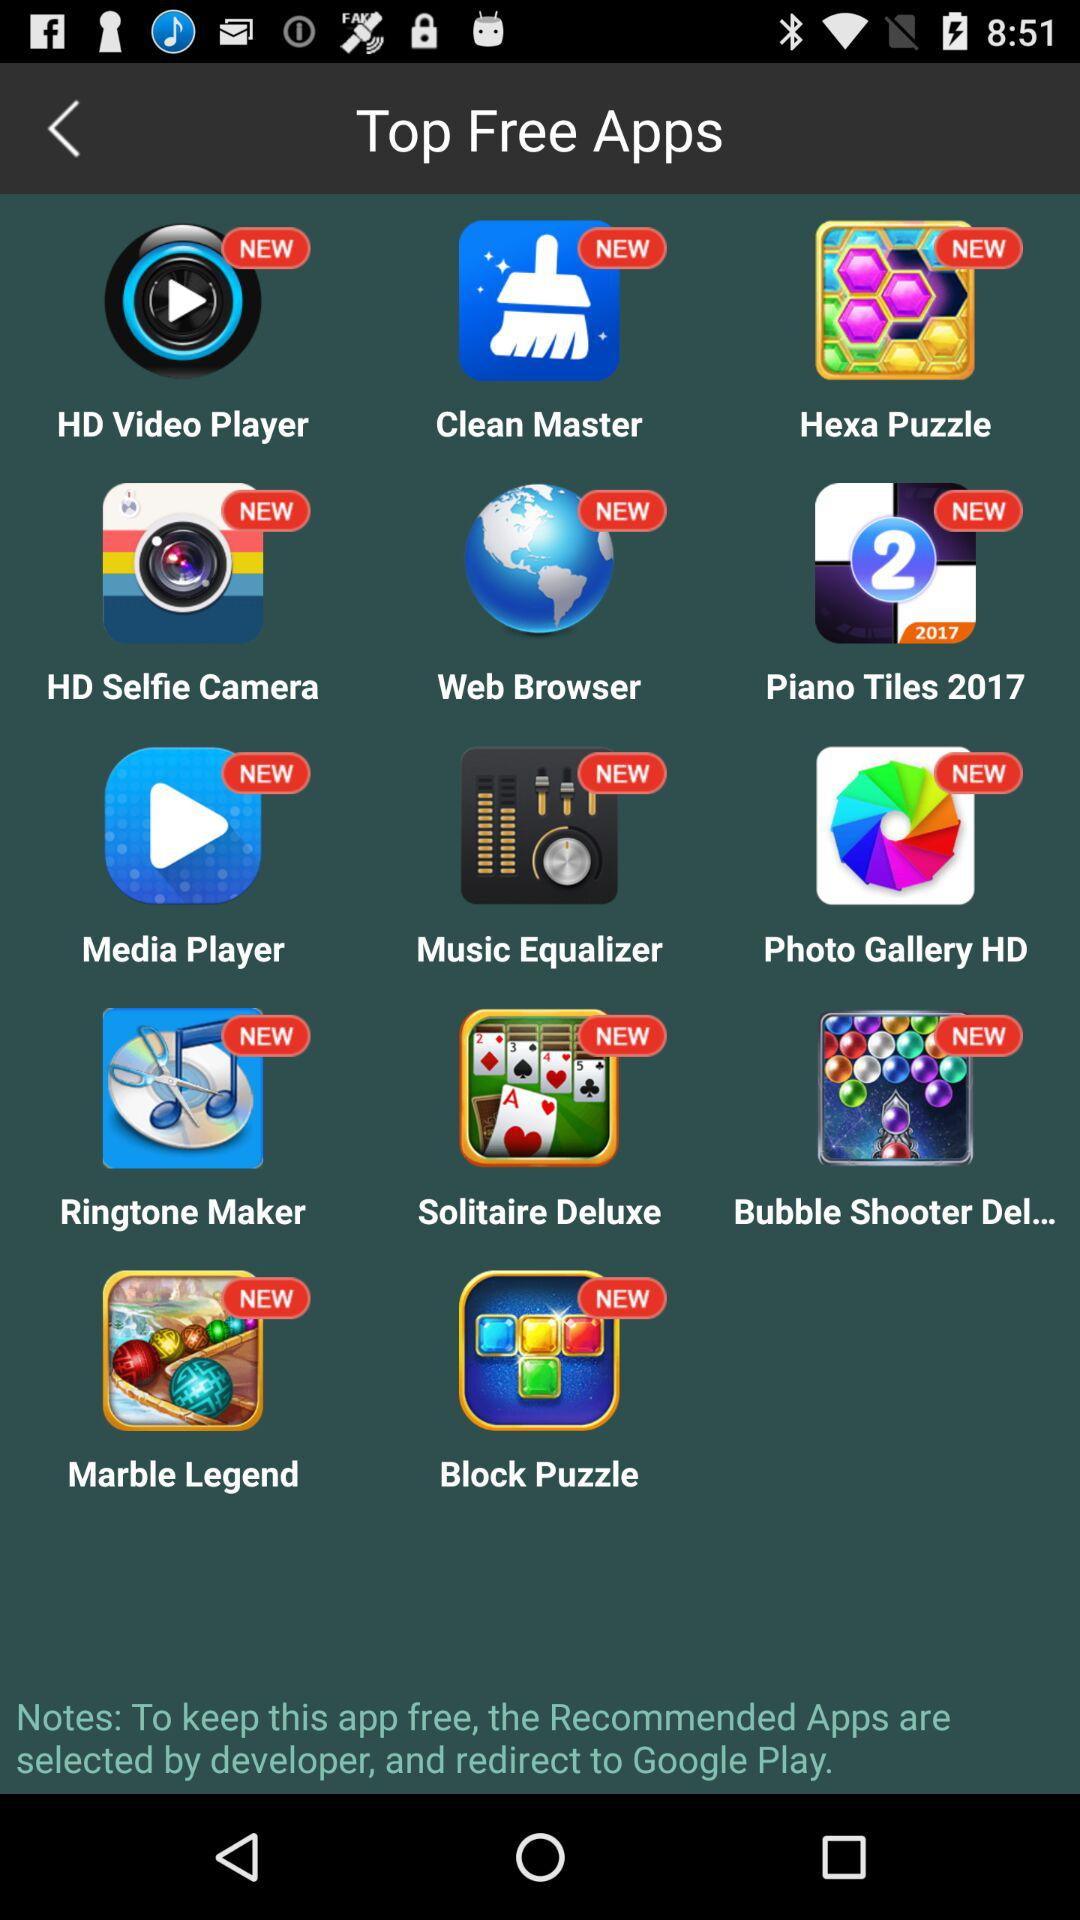Which camera app is available in free apps? The available camera app in free apps is "HD Selfie Camera". 